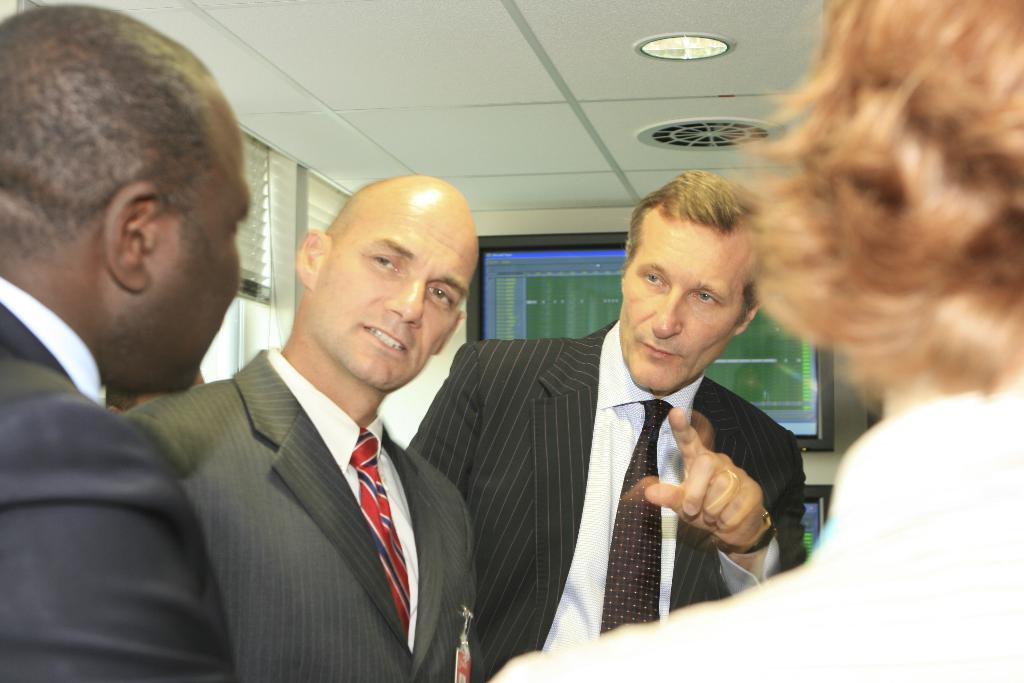What type of setting is depicted in the image? The image is an inside view. How many men are present in the image? There are four men in the image. What are the men wearing? The men are wearing suits. What are the men doing in the image? The men are discussing something. What can be seen on the wall in the background? There is a screen attached to the wall in the background. What is the source of light in the image? There is a light visible at the top of the image. What type of plate is being used by the men in the image? There is no plate visible in the image; the men are discussing something while wearing suits in an inside setting. Can you see any ships in the image? No, there are no ships present in the image. 